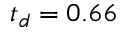Convert formula to latex. <formula><loc_0><loc_0><loc_500><loc_500>t _ { d } = 0 . 6 6</formula> 